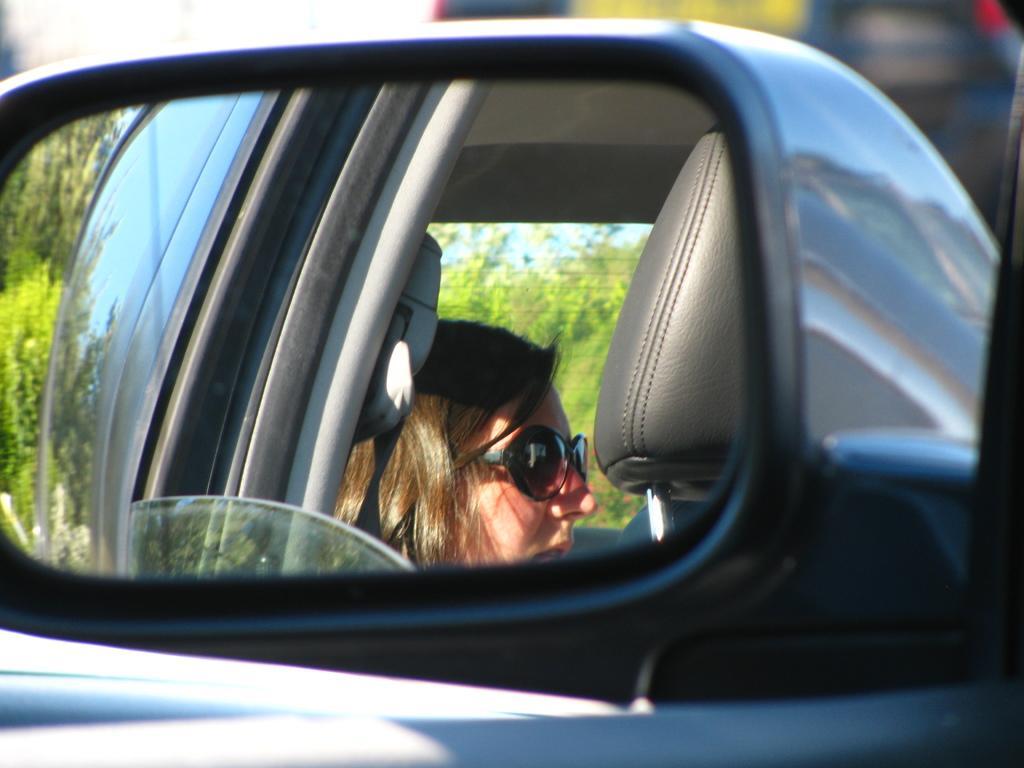Can you describe this image briefly? This is a mirror of a vehicle and through the glass we can see a lady wearing glasses and in the background, there are trees and some other vehicles. 